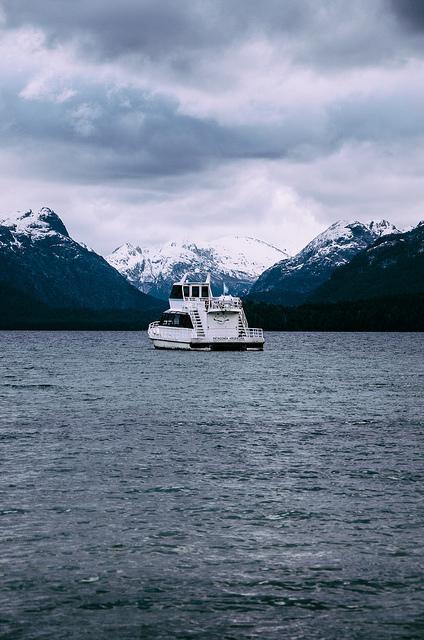How many boats in the photo?
Give a very brief answer. 1. How many boats are there?
Give a very brief answer. 1. How many boats are visible?
Give a very brief answer. 1. 